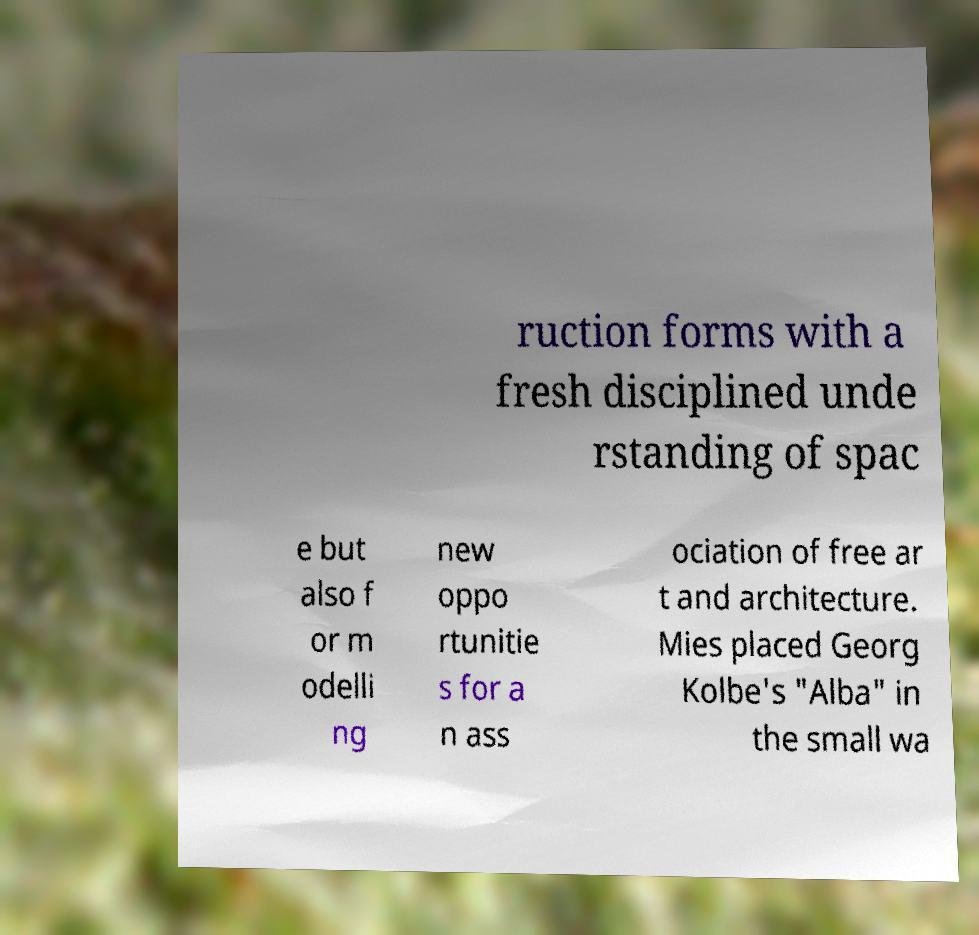Can you read and provide the text displayed in the image?This photo seems to have some interesting text. Can you extract and type it out for me? ruction forms with a fresh disciplined unde rstanding of spac e but also f or m odelli ng new oppo rtunitie s for a n ass ociation of free ar t and architecture. Mies placed Georg Kolbe's "Alba" in the small wa 